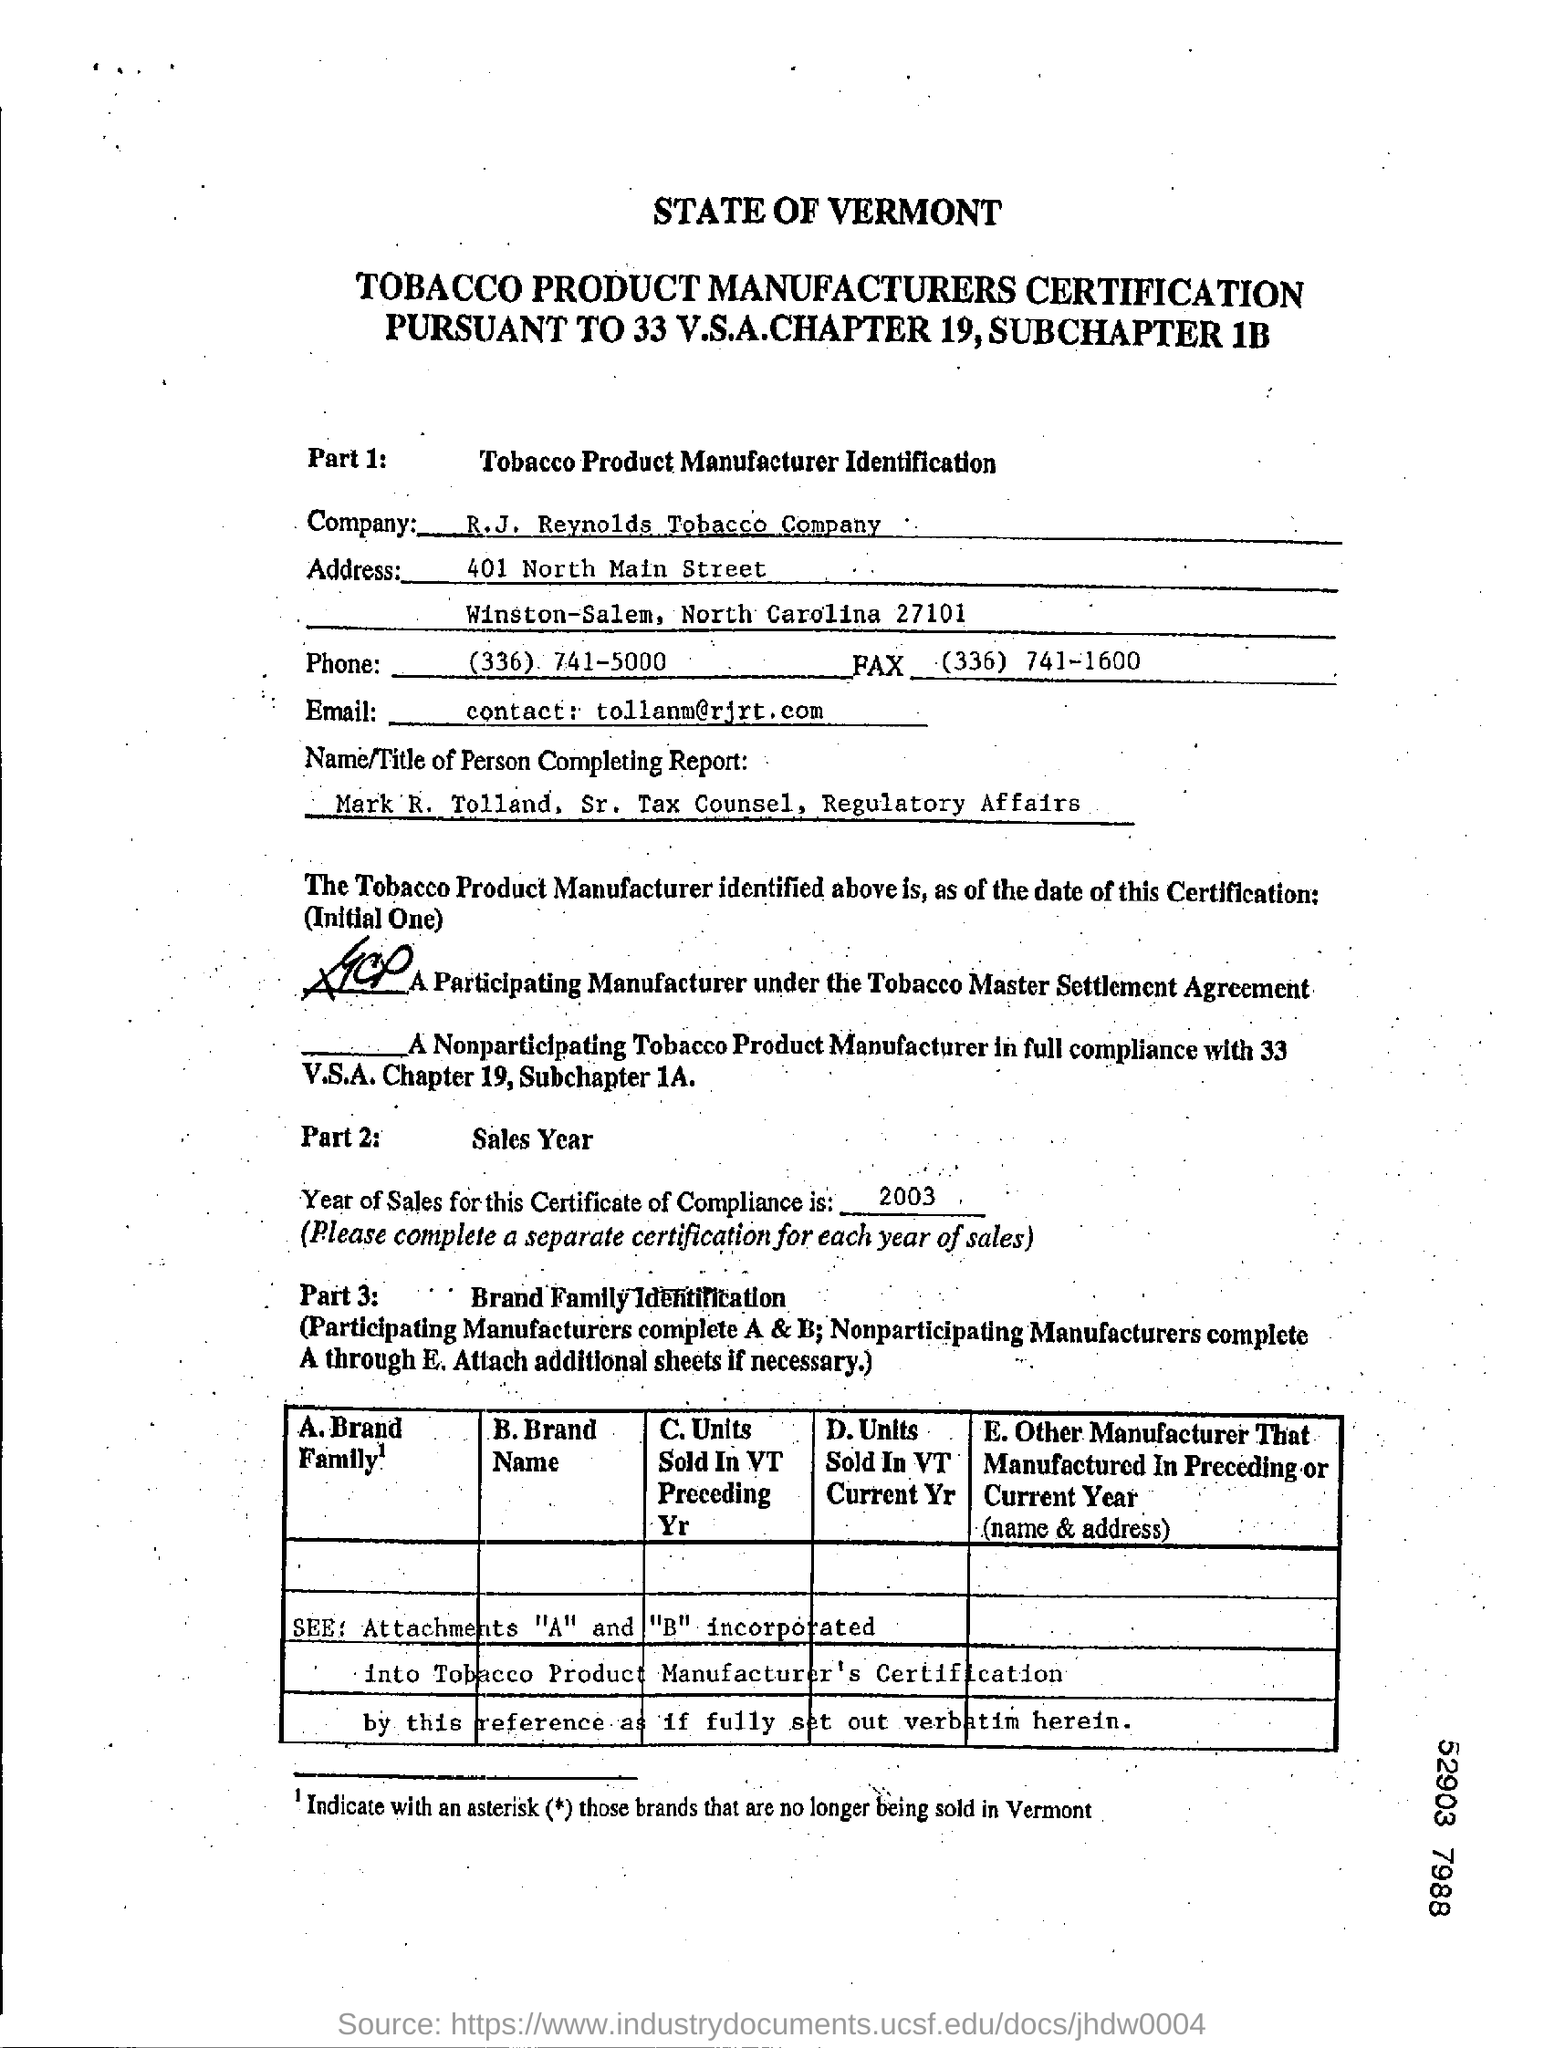Which company is certified for Tobacco Product Manufacturer?
Provide a short and direct response. R.J. Reynolds Tobacco Company. What is the fax no of the company?
Keep it short and to the point. (336) 741-1600. What is the title of the person completing the report?
Provide a short and direct response. Sr. Tax Counsel, Regulatory Affairs. Who completes the report?
Keep it short and to the point. Mark R.Tolland. What is the year of Sales for the Certificate of Compliance?
Offer a very short reply. 2003. 